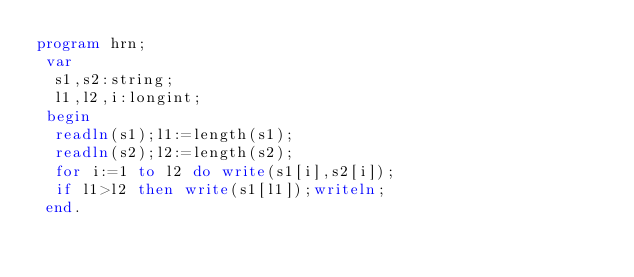<code> <loc_0><loc_0><loc_500><loc_500><_Pascal_>program hrn;
 var
  s1,s2:string;
  l1,l2,i:longint;
 begin
  readln(s1);l1:=length(s1);
  readln(s2);l2:=length(s2);
  for i:=1 to l2 do write(s1[i],s2[i]);
  if l1>l2 then write(s1[l1]);writeln;
 end.

</code> 